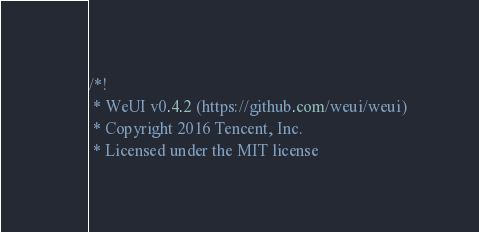Convert code to text. <code><loc_0><loc_0><loc_500><loc_500><_CSS_>/*!
 * WeUI v0.4.2 (https://github.com/weui/weui)
 * Copyright 2016 Tencent, Inc.
 * Licensed under the MIT license</code> 